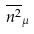Convert formula to latex. <formula><loc_0><loc_0><loc_500><loc_500>\overline { n ^ { 2 } } _ { \mu }</formula> 